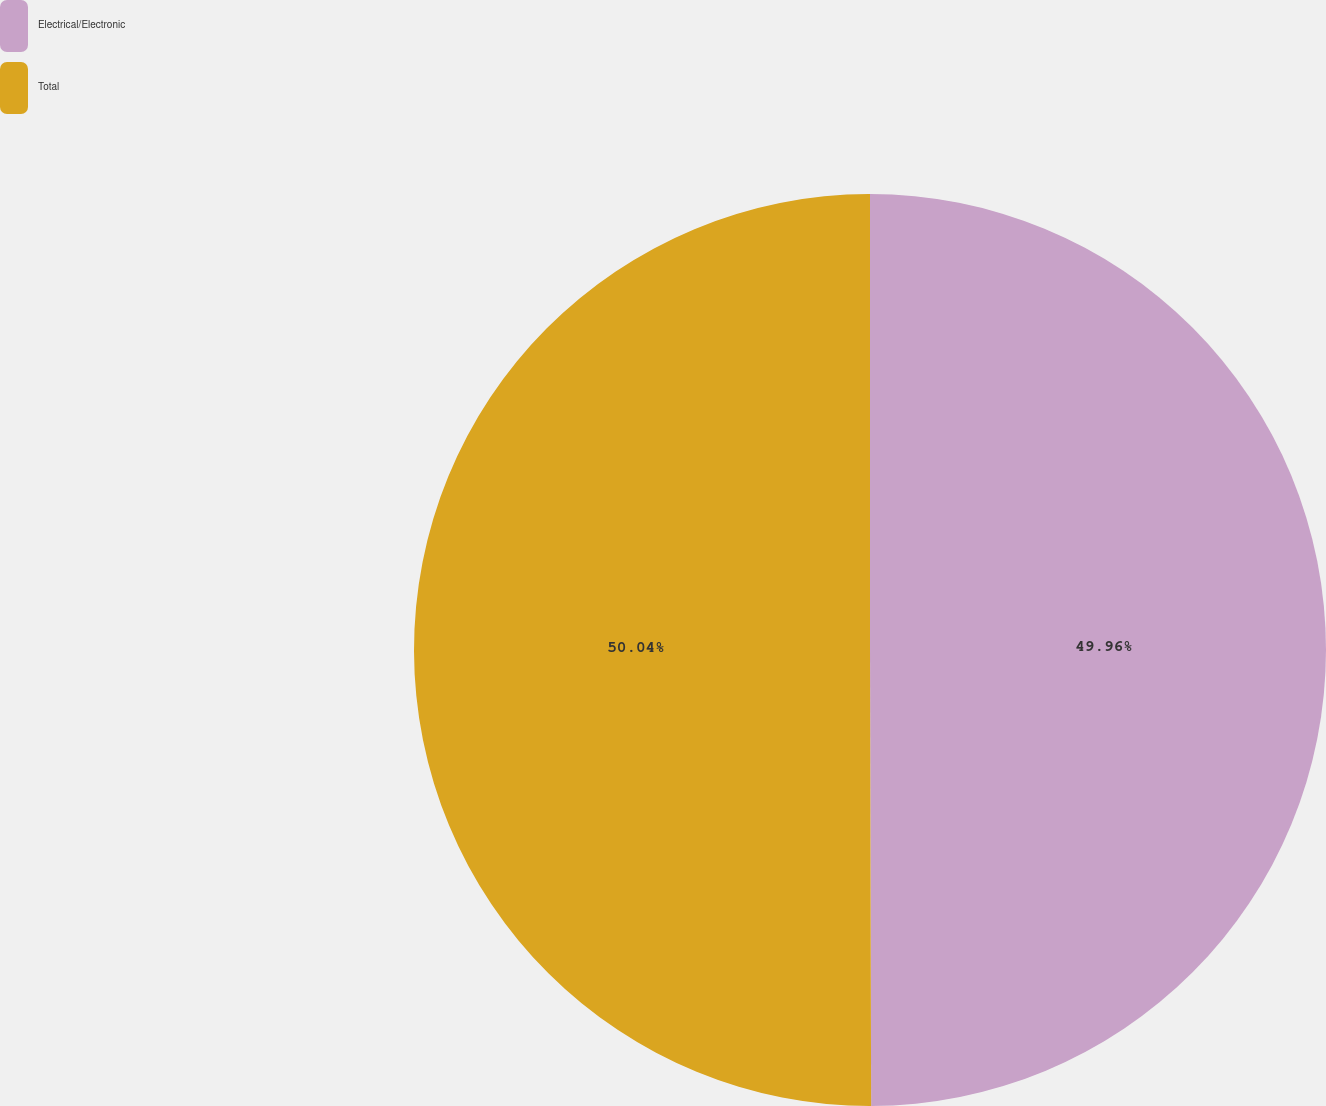Convert chart. <chart><loc_0><loc_0><loc_500><loc_500><pie_chart><fcel>Electrical/Electronic<fcel>Total<nl><fcel>49.96%<fcel>50.04%<nl></chart> 